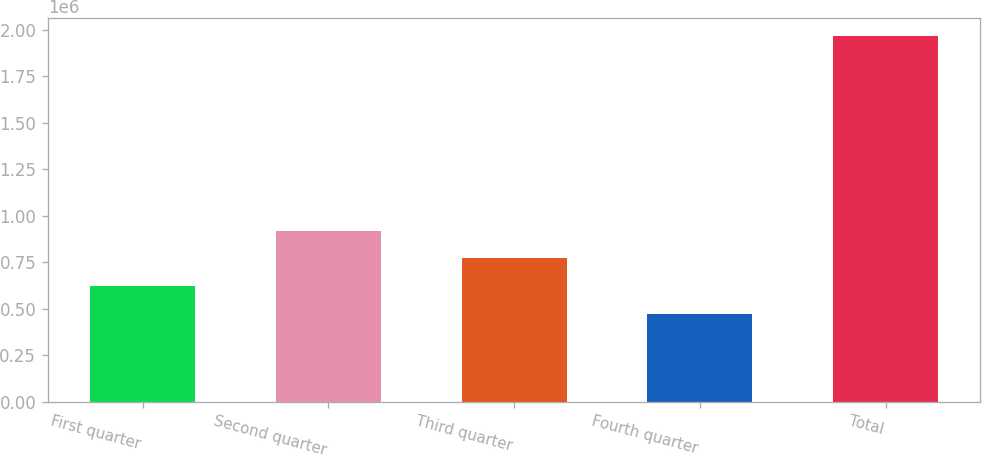Convert chart. <chart><loc_0><loc_0><loc_500><loc_500><bar_chart><fcel>First quarter<fcel>Second quarter<fcel>Third quarter<fcel>Fourth quarter<fcel>Total<nl><fcel>621180<fcel>919757<fcel>770468<fcel>471891<fcel>1.96478e+06<nl></chart> 